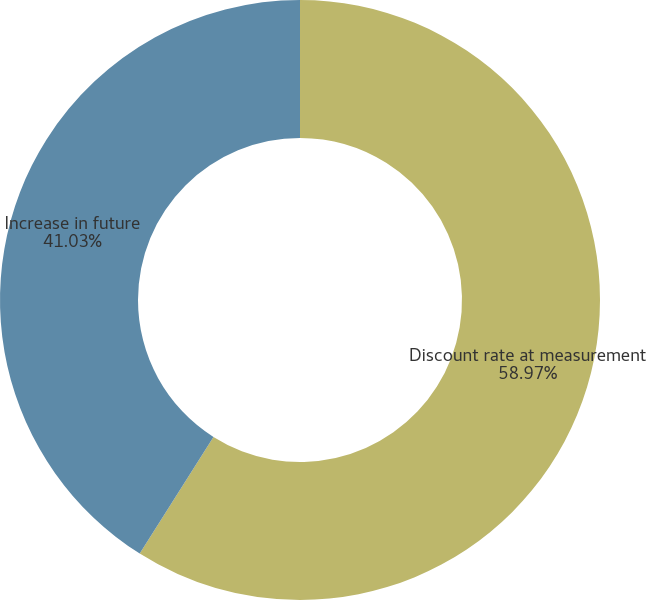Convert chart to OTSL. <chart><loc_0><loc_0><loc_500><loc_500><pie_chart><fcel>Discount rate at measurement<fcel>Increase in future<nl><fcel>58.97%<fcel>41.03%<nl></chart> 